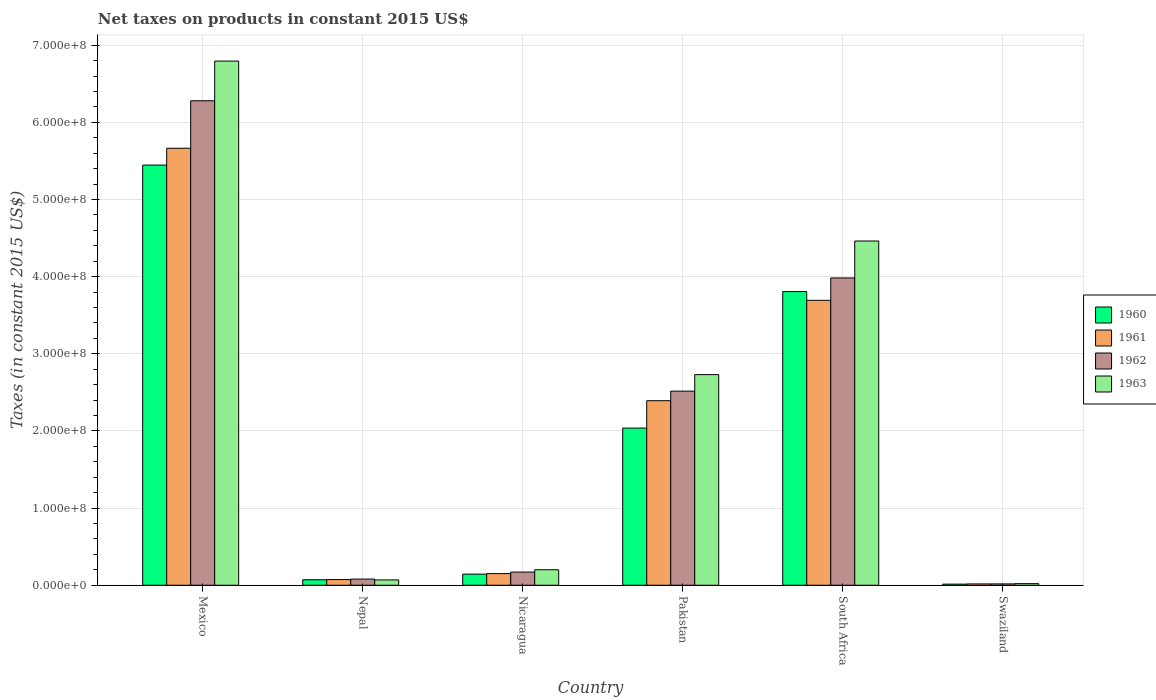How many different coloured bars are there?
Your answer should be very brief. 4. How many groups of bars are there?
Make the answer very short. 6. How many bars are there on the 1st tick from the right?
Keep it short and to the point. 4. What is the label of the 1st group of bars from the left?
Provide a succinct answer. Mexico. What is the net taxes on products in 1961 in Swaziland?
Provide a succinct answer. 1.69e+06. Across all countries, what is the maximum net taxes on products in 1960?
Your response must be concise. 5.45e+08. Across all countries, what is the minimum net taxes on products in 1963?
Keep it short and to the point. 2.06e+06. In which country was the net taxes on products in 1960 maximum?
Make the answer very short. Mexico. In which country was the net taxes on products in 1963 minimum?
Your response must be concise. Swaziland. What is the total net taxes on products in 1960 in the graph?
Ensure brevity in your answer.  1.15e+09. What is the difference between the net taxes on products in 1963 in Mexico and that in Nepal?
Offer a terse response. 6.72e+08. What is the difference between the net taxes on products in 1961 in Nepal and the net taxes on products in 1960 in South Africa?
Your answer should be very brief. -3.73e+08. What is the average net taxes on products in 1963 per country?
Your response must be concise. 2.38e+08. What is the difference between the net taxes on products of/in 1960 and net taxes on products of/in 1963 in Nepal?
Give a very brief answer. 1.97e+05. What is the ratio of the net taxes on products in 1961 in Mexico to that in South Africa?
Your answer should be compact. 1.53. Is the net taxes on products in 1962 in South Africa less than that in Swaziland?
Ensure brevity in your answer.  No. Is the difference between the net taxes on products in 1960 in Mexico and South Africa greater than the difference between the net taxes on products in 1963 in Mexico and South Africa?
Your answer should be compact. No. What is the difference between the highest and the second highest net taxes on products in 1962?
Offer a very short reply. 1.47e+08. What is the difference between the highest and the lowest net taxes on products in 1960?
Ensure brevity in your answer.  5.43e+08. How many countries are there in the graph?
Keep it short and to the point. 6. What is the difference between two consecutive major ticks on the Y-axis?
Make the answer very short. 1.00e+08. Are the values on the major ticks of Y-axis written in scientific E-notation?
Provide a short and direct response. Yes. Does the graph contain any zero values?
Provide a succinct answer. No. Does the graph contain grids?
Your answer should be compact. Yes. How many legend labels are there?
Your answer should be compact. 4. How are the legend labels stacked?
Keep it short and to the point. Vertical. What is the title of the graph?
Provide a short and direct response. Net taxes on products in constant 2015 US$. Does "2009" appear as one of the legend labels in the graph?
Your answer should be compact. No. What is the label or title of the Y-axis?
Your answer should be compact. Taxes (in constant 2015 US$). What is the Taxes (in constant 2015 US$) of 1960 in Mexico?
Keep it short and to the point. 5.45e+08. What is the Taxes (in constant 2015 US$) in 1961 in Mexico?
Ensure brevity in your answer.  5.66e+08. What is the Taxes (in constant 2015 US$) of 1962 in Mexico?
Make the answer very short. 6.28e+08. What is the Taxes (in constant 2015 US$) in 1963 in Mexico?
Your answer should be compact. 6.79e+08. What is the Taxes (in constant 2015 US$) in 1960 in Nepal?
Make the answer very short. 7.09e+06. What is the Taxes (in constant 2015 US$) of 1961 in Nepal?
Keep it short and to the point. 7.35e+06. What is the Taxes (in constant 2015 US$) in 1962 in Nepal?
Offer a very short reply. 8.01e+06. What is the Taxes (in constant 2015 US$) of 1963 in Nepal?
Provide a short and direct response. 6.89e+06. What is the Taxes (in constant 2015 US$) in 1960 in Nicaragua?
Provide a succinct answer. 1.44e+07. What is the Taxes (in constant 2015 US$) in 1961 in Nicaragua?
Offer a terse response. 1.51e+07. What is the Taxes (in constant 2015 US$) in 1962 in Nicaragua?
Offer a very short reply. 1.71e+07. What is the Taxes (in constant 2015 US$) in 1963 in Nicaragua?
Your answer should be compact. 2.01e+07. What is the Taxes (in constant 2015 US$) of 1960 in Pakistan?
Provide a succinct answer. 2.04e+08. What is the Taxes (in constant 2015 US$) of 1961 in Pakistan?
Give a very brief answer. 2.39e+08. What is the Taxes (in constant 2015 US$) of 1962 in Pakistan?
Offer a very short reply. 2.52e+08. What is the Taxes (in constant 2015 US$) in 1963 in Pakistan?
Provide a succinct answer. 2.73e+08. What is the Taxes (in constant 2015 US$) of 1960 in South Africa?
Offer a very short reply. 3.81e+08. What is the Taxes (in constant 2015 US$) in 1961 in South Africa?
Offer a very short reply. 3.69e+08. What is the Taxes (in constant 2015 US$) in 1962 in South Africa?
Ensure brevity in your answer.  3.98e+08. What is the Taxes (in constant 2015 US$) of 1963 in South Africa?
Make the answer very short. 4.46e+08. What is the Taxes (in constant 2015 US$) of 1960 in Swaziland?
Your answer should be compact. 1.40e+06. What is the Taxes (in constant 2015 US$) of 1961 in Swaziland?
Give a very brief answer. 1.69e+06. What is the Taxes (in constant 2015 US$) in 1962 in Swaziland?
Offer a terse response. 1.73e+06. What is the Taxes (in constant 2015 US$) in 1963 in Swaziland?
Provide a succinct answer. 2.06e+06. Across all countries, what is the maximum Taxes (in constant 2015 US$) of 1960?
Keep it short and to the point. 5.45e+08. Across all countries, what is the maximum Taxes (in constant 2015 US$) of 1961?
Ensure brevity in your answer.  5.66e+08. Across all countries, what is the maximum Taxes (in constant 2015 US$) of 1962?
Keep it short and to the point. 6.28e+08. Across all countries, what is the maximum Taxes (in constant 2015 US$) of 1963?
Make the answer very short. 6.79e+08. Across all countries, what is the minimum Taxes (in constant 2015 US$) of 1960?
Provide a short and direct response. 1.40e+06. Across all countries, what is the minimum Taxes (in constant 2015 US$) of 1961?
Your response must be concise. 1.69e+06. Across all countries, what is the minimum Taxes (in constant 2015 US$) of 1962?
Ensure brevity in your answer.  1.73e+06. Across all countries, what is the minimum Taxes (in constant 2015 US$) of 1963?
Offer a terse response. 2.06e+06. What is the total Taxes (in constant 2015 US$) of 1960 in the graph?
Keep it short and to the point. 1.15e+09. What is the total Taxes (in constant 2015 US$) in 1961 in the graph?
Make the answer very short. 1.20e+09. What is the total Taxes (in constant 2015 US$) of 1962 in the graph?
Your answer should be compact. 1.30e+09. What is the total Taxes (in constant 2015 US$) in 1963 in the graph?
Give a very brief answer. 1.43e+09. What is the difference between the Taxes (in constant 2015 US$) in 1960 in Mexico and that in Nepal?
Keep it short and to the point. 5.37e+08. What is the difference between the Taxes (in constant 2015 US$) of 1961 in Mexico and that in Nepal?
Provide a short and direct response. 5.59e+08. What is the difference between the Taxes (in constant 2015 US$) in 1962 in Mexico and that in Nepal?
Keep it short and to the point. 6.20e+08. What is the difference between the Taxes (in constant 2015 US$) in 1963 in Mexico and that in Nepal?
Offer a terse response. 6.72e+08. What is the difference between the Taxes (in constant 2015 US$) in 1960 in Mexico and that in Nicaragua?
Ensure brevity in your answer.  5.30e+08. What is the difference between the Taxes (in constant 2015 US$) in 1961 in Mexico and that in Nicaragua?
Your response must be concise. 5.51e+08. What is the difference between the Taxes (in constant 2015 US$) of 1962 in Mexico and that in Nicaragua?
Provide a short and direct response. 6.11e+08. What is the difference between the Taxes (in constant 2015 US$) of 1963 in Mexico and that in Nicaragua?
Offer a very short reply. 6.59e+08. What is the difference between the Taxes (in constant 2015 US$) of 1960 in Mexico and that in Pakistan?
Make the answer very short. 3.41e+08. What is the difference between the Taxes (in constant 2015 US$) of 1961 in Mexico and that in Pakistan?
Your answer should be compact. 3.27e+08. What is the difference between the Taxes (in constant 2015 US$) in 1962 in Mexico and that in Pakistan?
Keep it short and to the point. 3.76e+08. What is the difference between the Taxes (in constant 2015 US$) in 1963 in Mexico and that in Pakistan?
Keep it short and to the point. 4.06e+08. What is the difference between the Taxes (in constant 2015 US$) in 1960 in Mexico and that in South Africa?
Your response must be concise. 1.64e+08. What is the difference between the Taxes (in constant 2015 US$) in 1961 in Mexico and that in South Africa?
Your answer should be compact. 1.97e+08. What is the difference between the Taxes (in constant 2015 US$) of 1962 in Mexico and that in South Africa?
Your response must be concise. 2.30e+08. What is the difference between the Taxes (in constant 2015 US$) in 1963 in Mexico and that in South Africa?
Offer a terse response. 2.33e+08. What is the difference between the Taxes (in constant 2015 US$) in 1960 in Mexico and that in Swaziland?
Offer a very short reply. 5.43e+08. What is the difference between the Taxes (in constant 2015 US$) in 1961 in Mexico and that in Swaziland?
Provide a short and direct response. 5.65e+08. What is the difference between the Taxes (in constant 2015 US$) in 1962 in Mexico and that in Swaziland?
Keep it short and to the point. 6.26e+08. What is the difference between the Taxes (in constant 2015 US$) of 1963 in Mexico and that in Swaziland?
Keep it short and to the point. 6.77e+08. What is the difference between the Taxes (in constant 2015 US$) in 1960 in Nepal and that in Nicaragua?
Make the answer very short. -7.30e+06. What is the difference between the Taxes (in constant 2015 US$) of 1961 in Nepal and that in Nicaragua?
Your answer should be compact. -7.71e+06. What is the difference between the Taxes (in constant 2015 US$) of 1962 in Nepal and that in Nicaragua?
Your response must be concise. -9.06e+06. What is the difference between the Taxes (in constant 2015 US$) of 1963 in Nepal and that in Nicaragua?
Provide a short and direct response. -1.32e+07. What is the difference between the Taxes (in constant 2015 US$) in 1960 in Nepal and that in Pakistan?
Your response must be concise. -1.97e+08. What is the difference between the Taxes (in constant 2015 US$) in 1961 in Nepal and that in Pakistan?
Your answer should be compact. -2.32e+08. What is the difference between the Taxes (in constant 2015 US$) of 1962 in Nepal and that in Pakistan?
Ensure brevity in your answer.  -2.44e+08. What is the difference between the Taxes (in constant 2015 US$) of 1963 in Nepal and that in Pakistan?
Keep it short and to the point. -2.66e+08. What is the difference between the Taxes (in constant 2015 US$) of 1960 in Nepal and that in South Africa?
Your answer should be compact. -3.74e+08. What is the difference between the Taxes (in constant 2015 US$) in 1961 in Nepal and that in South Africa?
Ensure brevity in your answer.  -3.62e+08. What is the difference between the Taxes (in constant 2015 US$) of 1962 in Nepal and that in South Africa?
Your answer should be very brief. -3.90e+08. What is the difference between the Taxes (in constant 2015 US$) of 1963 in Nepal and that in South Africa?
Keep it short and to the point. -4.39e+08. What is the difference between the Taxes (in constant 2015 US$) of 1960 in Nepal and that in Swaziland?
Your answer should be compact. 5.68e+06. What is the difference between the Taxes (in constant 2015 US$) of 1961 in Nepal and that in Swaziland?
Your answer should be compact. 5.66e+06. What is the difference between the Taxes (in constant 2015 US$) of 1962 in Nepal and that in Swaziland?
Offer a very short reply. 6.27e+06. What is the difference between the Taxes (in constant 2015 US$) of 1963 in Nepal and that in Swaziland?
Your response must be concise. 4.83e+06. What is the difference between the Taxes (in constant 2015 US$) of 1960 in Nicaragua and that in Pakistan?
Ensure brevity in your answer.  -1.89e+08. What is the difference between the Taxes (in constant 2015 US$) in 1961 in Nicaragua and that in Pakistan?
Make the answer very short. -2.24e+08. What is the difference between the Taxes (in constant 2015 US$) in 1962 in Nicaragua and that in Pakistan?
Provide a short and direct response. -2.35e+08. What is the difference between the Taxes (in constant 2015 US$) in 1963 in Nicaragua and that in Pakistan?
Offer a very short reply. -2.53e+08. What is the difference between the Taxes (in constant 2015 US$) of 1960 in Nicaragua and that in South Africa?
Your response must be concise. -3.66e+08. What is the difference between the Taxes (in constant 2015 US$) in 1961 in Nicaragua and that in South Africa?
Give a very brief answer. -3.54e+08. What is the difference between the Taxes (in constant 2015 US$) in 1962 in Nicaragua and that in South Africa?
Offer a terse response. -3.81e+08. What is the difference between the Taxes (in constant 2015 US$) of 1963 in Nicaragua and that in South Africa?
Give a very brief answer. -4.26e+08. What is the difference between the Taxes (in constant 2015 US$) of 1960 in Nicaragua and that in Swaziland?
Ensure brevity in your answer.  1.30e+07. What is the difference between the Taxes (in constant 2015 US$) of 1961 in Nicaragua and that in Swaziland?
Your answer should be very brief. 1.34e+07. What is the difference between the Taxes (in constant 2015 US$) of 1962 in Nicaragua and that in Swaziland?
Ensure brevity in your answer.  1.53e+07. What is the difference between the Taxes (in constant 2015 US$) in 1963 in Nicaragua and that in Swaziland?
Provide a succinct answer. 1.80e+07. What is the difference between the Taxes (in constant 2015 US$) of 1960 in Pakistan and that in South Africa?
Your answer should be very brief. -1.77e+08. What is the difference between the Taxes (in constant 2015 US$) of 1961 in Pakistan and that in South Africa?
Offer a terse response. -1.30e+08. What is the difference between the Taxes (in constant 2015 US$) in 1962 in Pakistan and that in South Africa?
Your answer should be very brief. -1.47e+08. What is the difference between the Taxes (in constant 2015 US$) in 1963 in Pakistan and that in South Africa?
Offer a terse response. -1.73e+08. What is the difference between the Taxes (in constant 2015 US$) of 1960 in Pakistan and that in Swaziland?
Provide a succinct answer. 2.02e+08. What is the difference between the Taxes (in constant 2015 US$) of 1961 in Pakistan and that in Swaziland?
Ensure brevity in your answer.  2.37e+08. What is the difference between the Taxes (in constant 2015 US$) in 1962 in Pakistan and that in Swaziland?
Offer a very short reply. 2.50e+08. What is the difference between the Taxes (in constant 2015 US$) of 1963 in Pakistan and that in Swaziland?
Keep it short and to the point. 2.71e+08. What is the difference between the Taxes (in constant 2015 US$) in 1960 in South Africa and that in Swaziland?
Offer a very short reply. 3.79e+08. What is the difference between the Taxes (in constant 2015 US$) in 1961 in South Africa and that in Swaziland?
Keep it short and to the point. 3.68e+08. What is the difference between the Taxes (in constant 2015 US$) in 1962 in South Africa and that in Swaziland?
Provide a short and direct response. 3.97e+08. What is the difference between the Taxes (in constant 2015 US$) of 1963 in South Africa and that in Swaziland?
Make the answer very short. 4.44e+08. What is the difference between the Taxes (in constant 2015 US$) of 1960 in Mexico and the Taxes (in constant 2015 US$) of 1961 in Nepal?
Offer a terse response. 5.37e+08. What is the difference between the Taxes (in constant 2015 US$) of 1960 in Mexico and the Taxes (in constant 2015 US$) of 1962 in Nepal?
Your response must be concise. 5.37e+08. What is the difference between the Taxes (in constant 2015 US$) of 1960 in Mexico and the Taxes (in constant 2015 US$) of 1963 in Nepal?
Provide a succinct answer. 5.38e+08. What is the difference between the Taxes (in constant 2015 US$) in 1961 in Mexico and the Taxes (in constant 2015 US$) in 1962 in Nepal?
Offer a very short reply. 5.58e+08. What is the difference between the Taxes (in constant 2015 US$) in 1961 in Mexico and the Taxes (in constant 2015 US$) in 1963 in Nepal?
Give a very brief answer. 5.60e+08. What is the difference between the Taxes (in constant 2015 US$) of 1962 in Mexico and the Taxes (in constant 2015 US$) of 1963 in Nepal?
Offer a terse response. 6.21e+08. What is the difference between the Taxes (in constant 2015 US$) of 1960 in Mexico and the Taxes (in constant 2015 US$) of 1961 in Nicaragua?
Your answer should be very brief. 5.30e+08. What is the difference between the Taxes (in constant 2015 US$) of 1960 in Mexico and the Taxes (in constant 2015 US$) of 1962 in Nicaragua?
Provide a succinct answer. 5.28e+08. What is the difference between the Taxes (in constant 2015 US$) of 1960 in Mexico and the Taxes (in constant 2015 US$) of 1963 in Nicaragua?
Your answer should be compact. 5.24e+08. What is the difference between the Taxes (in constant 2015 US$) of 1961 in Mexico and the Taxes (in constant 2015 US$) of 1962 in Nicaragua?
Provide a short and direct response. 5.49e+08. What is the difference between the Taxes (in constant 2015 US$) in 1961 in Mexico and the Taxes (in constant 2015 US$) in 1963 in Nicaragua?
Ensure brevity in your answer.  5.46e+08. What is the difference between the Taxes (in constant 2015 US$) in 1962 in Mexico and the Taxes (in constant 2015 US$) in 1963 in Nicaragua?
Your answer should be compact. 6.08e+08. What is the difference between the Taxes (in constant 2015 US$) in 1960 in Mexico and the Taxes (in constant 2015 US$) in 1961 in Pakistan?
Your answer should be very brief. 3.05e+08. What is the difference between the Taxes (in constant 2015 US$) of 1960 in Mexico and the Taxes (in constant 2015 US$) of 1962 in Pakistan?
Offer a very short reply. 2.93e+08. What is the difference between the Taxes (in constant 2015 US$) in 1960 in Mexico and the Taxes (in constant 2015 US$) in 1963 in Pakistan?
Offer a terse response. 2.72e+08. What is the difference between the Taxes (in constant 2015 US$) in 1961 in Mexico and the Taxes (in constant 2015 US$) in 1962 in Pakistan?
Offer a very short reply. 3.15e+08. What is the difference between the Taxes (in constant 2015 US$) in 1961 in Mexico and the Taxes (in constant 2015 US$) in 1963 in Pakistan?
Provide a succinct answer. 2.93e+08. What is the difference between the Taxes (in constant 2015 US$) of 1962 in Mexico and the Taxes (in constant 2015 US$) of 1963 in Pakistan?
Offer a very short reply. 3.55e+08. What is the difference between the Taxes (in constant 2015 US$) in 1960 in Mexico and the Taxes (in constant 2015 US$) in 1961 in South Africa?
Offer a very short reply. 1.75e+08. What is the difference between the Taxes (in constant 2015 US$) of 1960 in Mexico and the Taxes (in constant 2015 US$) of 1962 in South Africa?
Ensure brevity in your answer.  1.46e+08. What is the difference between the Taxes (in constant 2015 US$) of 1960 in Mexico and the Taxes (in constant 2015 US$) of 1963 in South Africa?
Provide a short and direct response. 9.84e+07. What is the difference between the Taxes (in constant 2015 US$) of 1961 in Mexico and the Taxes (in constant 2015 US$) of 1962 in South Africa?
Your answer should be compact. 1.68e+08. What is the difference between the Taxes (in constant 2015 US$) in 1961 in Mexico and the Taxes (in constant 2015 US$) in 1963 in South Africa?
Keep it short and to the point. 1.20e+08. What is the difference between the Taxes (in constant 2015 US$) in 1962 in Mexico and the Taxes (in constant 2015 US$) in 1963 in South Africa?
Give a very brief answer. 1.82e+08. What is the difference between the Taxes (in constant 2015 US$) of 1960 in Mexico and the Taxes (in constant 2015 US$) of 1961 in Swaziland?
Make the answer very short. 5.43e+08. What is the difference between the Taxes (in constant 2015 US$) in 1960 in Mexico and the Taxes (in constant 2015 US$) in 1962 in Swaziland?
Make the answer very short. 5.43e+08. What is the difference between the Taxes (in constant 2015 US$) in 1960 in Mexico and the Taxes (in constant 2015 US$) in 1963 in Swaziland?
Offer a terse response. 5.43e+08. What is the difference between the Taxes (in constant 2015 US$) of 1961 in Mexico and the Taxes (in constant 2015 US$) of 1962 in Swaziland?
Provide a succinct answer. 5.65e+08. What is the difference between the Taxes (in constant 2015 US$) in 1961 in Mexico and the Taxes (in constant 2015 US$) in 1963 in Swaziland?
Offer a terse response. 5.64e+08. What is the difference between the Taxes (in constant 2015 US$) in 1962 in Mexico and the Taxes (in constant 2015 US$) in 1963 in Swaziland?
Keep it short and to the point. 6.26e+08. What is the difference between the Taxes (in constant 2015 US$) of 1960 in Nepal and the Taxes (in constant 2015 US$) of 1961 in Nicaragua?
Give a very brief answer. -7.97e+06. What is the difference between the Taxes (in constant 2015 US$) of 1960 in Nepal and the Taxes (in constant 2015 US$) of 1962 in Nicaragua?
Make the answer very short. -9.98e+06. What is the difference between the Taxes (in constant 2015 US$) in 1960 in Nepal and the Taxes (in constant 2015 US$) in 1963 in Nicaragua?
Your response must be concise. -1.30e+07. What is the difference between the Taxes (in constant 2015 US$) in 1961 in Nepal and the Taxes (in constant 2015 US$) in 1962 in Nicaragua?
Provide a short and direct response. -9.71e+06. What is the difference between the Taxes (in constant 2015 US$) in 1961 in Nepal and the Taxes (in constant 2015 US$) in 1963 in Nicaragua?
Your answer should be compact. -1.27e+07. What is the difference between the Taxes (in constant 2015 US$) in 1962 in Nepal and the Taxes (in constant 2015 US$) in 1963 in Nicaragua?
Your answer should be compact. -1.21e+07. What is the difference between the Taxes (in constant 2015 US$) of 1960 in Nepal and the Taxes (in constant 2015 US$) of 1961 in Pakistan?
Keep it short and to the point. -2.32e+08. What is the difference between the Taxes (in constant 2015 US$) in 1960 in Nepal and the Taxes (in constant 2015 US$) in 1962 in Pakistan?
Offer a terse response. -2.44e+08. What is the difference between the Taxes (in constant 2015 US$) in 1960 in Nepal and the Taxes (in constant 2015 US$) in 1963 in Pakistan?
Ensure brevity in your answer.  -2.66e+08. What is the difference between the Taxes (in constant 2015 US$) in 1961 in Nepal and the Taxes (in constant 2015 US$) in 1962 in Pakistan?
Make the answer very short. -2.44e+08. What is the difference between the Taxes (in constant 2015 US$) of 1961 in Nepal and the Taxes (in constant 2015 US$) of 1963 in Pakistan?
Offer a very short reply. -2.66e+08. What is the difference between the Taxes (in constant 2015 US$) of 1962 in Nepal and the Taxes (in constant 2015 US$) of 1963 in Pakistan?
Give a very brief answer. -2.65e+08. What is the difference between the Taxes (in constant 2015 US$) of 1960 in Nepal and the Taxes (in constant 2015 US$) of 1961 in South Africa?
Provide a succinct answer. -3.62e+08. What is the difference between the Taxes (in constant 2015 US$) in 1960 in Nepal and the Taxes (in constant 2015 US$) in 1962 in South Africa?
Provide a short and direct response. -3.91e+08. What is the difference between the Taxes (in constant 2015 US$) in 1960 in Nepal and the Taxes (in constant 2015 US$) in 1963 in South Africa?
Offer a very short reply. -4.39e+08. What is the difference between the Taxes (in constant 2015 US$) of 1961 in Nepal and the Taxes (in constant 2015 US$) of 1962 in South Africa?
Keep it short and to the point. -3.91e+08. What is the difference between the Taxes (in constant 2015 US$) of 1961 in Nepal and the Taxes (in constant 2015 US$) of 1963 in South Africa?
Offer a terse response. -4.39e+08. What is the difference between the Taxes (in constant 2015 US$) of 1962 in Nepal and the Taxes (in constant 2015 US$) of 1963 in South Africa?
Your answer should be very brief. -4.38e+08. What is the difference between the Taxes (in constant 2015 US$) in 1960 in Nepal and the Taxes (in constant 2015 US$) in 1961 in Swaziland?
Offer a very short reply. 5.39e+06. What is the difference between the Taxes (in constant 2015 US$) of 1960 in Nepal and the Taxes (in constant 2015 US$) of 1962 in Swaziland?
Your response must be concise. 5.35e+06. What is the difference between the Taxes (in constant 2015 US$) in 1960 in Nepal and the Taxes (in constant 2015 US$) in 1963 in Swaziland?
Your answer should be compact. 5.02e+06. What is the difference between the Taxes (in constant 2015 US$) of 1961 in Nepal and the Taxes (in constant 2015 US$) of 1962 in Swaziland?
Your answer should be very brief. 5.62e+06. What is the difference between the Taxes (in constant 2015 US$) of 1961 in Nepal and the Taxes (in constant 2015 US$) of 1963 in Swaziland?
Give a very brief answer. 5.29e+06. What is the difference between the Taxes (in constant 2015 US$) of 1962 in Nepal and the Taxes (in constant 2015 US$) of 1963 in Swaziland?
Provide a succinct answer. 5.94e+06. What is the difference between the Taxes (in constant 2015 US$) of 1960 in Nicaragua and the Taxes (in constant 2015 US$) of 1961 in Pakistan?
Make the answer very short. -2.25e+08. What is the difference between the Taxes (in constant 2015 US$) of 1960 in Nicaragua and the Taxes (in constant 2015 US$) of 1962 in Pakistan?
Provide a succinct answer. -2.37e+08. What is the difference between the Taxes (in constant 2015 US$) in 1960 in Nicaragua and the Taxes (in constant 2015 US$) in 1963 in Pakistan?
Offer a very short reply. -2.59e+08. What is the difference between the Taxes (in constant 2015 US$) in 1961 in Nicaragua and the Taxes (in constant 2015 US$) in 1962 in Pakistan?
Give a very brief answer. -2.37e+08. What is the difference between the Taxes (in constant 2015 US$) in 1961 in Nicaragua and the Taxes (in constant 2015 US$) in 1963 in Pakistan?
Give a very brief answer. -2.58e+08. What is the difference between the Taxes (in constant 2015 US$) in 1962 in Nicaragua and the Taxes (in constant 2015 US$) in 1963 in Pakistan?
Offer a very short reply. -2.56e+08. What is the difference between the Taxes (in constant 2015 US$) of 1960 in Nicaragua and the Taxes (in constant 2015 US$) of 1961 in South Africa?
Provide a short and direct response. -3.55e+08. What is the difference between the Taxes (in constant 2015 US$) in 1960 in Nicaragua and the Taxes (in constant 2015 US$) in 1962 in South Africa?
Give a very brief answer. -3.84e+08. What is the difference between the Taxes (in constant 2015 US$) in 1960 in Nicaragua and the Taxes (in constant 2015 US$) in 1963 in South Africa?
Your answer should be compact. -4.32e+08. What is the difference between the Taxes (in constant 2015 US$) of 1961 in Nicaragua and the Taxes (in constant 2015 US$) of 1962 in South Africa?
Your response must be concise. -3.83e+08. What is the difference between the Taxes (in constant 2015 US$) of 1961 in Nicaragua and the Taxes (in constant 2015 US$) of 1963 in South Africa?
Your answer should be very brief. -4.31e+08. What is the difference between the Taxes (in constant 2015 US$) in 1962 in Nicaragua and the Taxes (in constant 2015 US$) in 1963 in South Africa?
Keep it short and to the point. -4.29e+08. What is the difference between the Taxes (in constant 2015 US$) of 1960 in Nicaragua and the Taxes (in constant 2015 US$) of 1961 in Swaziland?
Your answer should be very brief. 1.27e+07. What is the difference between the Taxes (in constant 2015 US$) of 1960 in Nicaragua and the Taxes (in constant 2015 US$) of 1962 in Swaziland?
Provide a short and direct response. 1.27e+07. What is the difference between the Taxes (in constant 2015 US$) of 1960 in Nicaragua and the Taxes (in constant 2015 US$) of 1963 in Swaziland?
Your response must be concise. 1.23e+07. What is the difference between the Taxes (in constant 2015 US$) of 1961 in Nicaragua and the Taxes (in constant 2015 US$) of 1962 in Swaziland?
Provide a short and direct response. 1.33e+07. What is the difference between the Taxes (in constant 2015 US$) in 1961 in Nicaragua and the Taxes (in constant 2015 US$) in 1963 in Swaziland?
Provide a succinct answer. 1.30e+07. What is the difference between the Taxes (in constant 2015 US$) in 1962 in Nicaragua and the Taxes (in constant 2015 US$) in 1963 in Swaziland?
Provide a short and direct response. 1.50e+07. What is the difference between the Taxes (in constant 2015 US$) of 1960 in Pakistan and the Taxes (in constant 2015 US$) of 1961 in South Africa?
Provide a succinct answer. -1.66e+08. What is the difference between the Taxes (in constant 2015 US$) in 1960 in Pakistan and the Taxes (in constant 2015 US$) in 1962 in South Africa?
Your response must be concise. -1.95e+08. What is the difference between the Taxes (in constant 2015 US$) of 1960 in Pakistan and the Taxes (in constant 2015 US$) of 1963 in South Africa?
Offer a very short reply. -2.42e+08. What is the difference between the Taxes (in constant 2015 US$) of 1961 in Pakistan and the Taxes (in constant 2015 US$) of 1962 in South Africa?
Make the answer very short. -1.59e+08. What is the difference between the Taxes (in constant 2015 US$) in 1961 in Pakistan and the Taxes (in constant 2015 US$) in 1963 in South Africa?
Provide a short and direct response. -2.07e+08. What is the difference between the Taxes (in constant 2015 US$) in 1962 in Pakistan and the Taxes (in constant 2015 US$) in 1963 in South Africa?
Your answer should be compact. -1.95e+08. What is the difference between the Taxes (in constant 2015 US$) in 1960 in Pakistan and the Taxes (in constant 2015 US$) in 1961 in Swaziland?
Your answer should be very brief. 2.02e+08. What is the difference between the Taxes (in constant 2015 US$) of 1960 in Pakistan and the Taxes (in constant 2015 US$) of 1962 in Swaziland?
Offer a very short reply. 2.02e+08. What is the difference between the Taxes (in constant 2015 US$) in 1960 in Pakistan and the Taxes (in constant 2015 US$) in 1963 in Swaziland?
Ensure brevity in your answer.  2.02e+08. What is the difference between the Taxes (in constant 2015 US$) in 1961 in Pakistan and the Taxes (in constant 2015 US$) in 1962 in Swaziland?
Keep it short and to the point. 2.37e+08. What is the difference between the Taxes (in constant 2015 US$) in 1961 in Pakistan and the Taxes (in constant 2015 US$) in 1963 in Swaziland?
Offer a terse response. 2.37e+08. What is the difference between the Taxes (in constant 2015 US$) in 1962 in Pakistan and the Taxes (in constant 2015 US$) in 1963 in Swaziland?
Your answer should be very brief. 2.50e+08. What is the difference between the Taxes (in constant 2015 US$) in 1960 in South Africa and the Taxes (in constant 2015 US$) in 1961 in Swaziland?
Give a very brief answer. 3.79e+08. What is the difference between the Taxes (in constant 2015 US$) in 1960 in South Africa and the Taxes (in constant 2015 US$) in 1962 in Swaziland?
Your response must be concise. 3.79e+08. What is the difference between the Taxes (in constant 2015 US$) of 1960 in South Africa and the Taxes (in constant 2015 US$) of 1963 in Swaziland?
Ensure brevity in your answer.  3.79e+08. What is the difference between the Taxes (in constant 2015 US$) in 1961 in South Africa and the Taxes (in constant 2015 US$) in 1962 in Swaziland?
Provide a short and direct response. 3.68e+08. What is the difference between the Taxes (in constant 2015 US$) of 1961 in South Africa and the Taxes (in constant 2015 US$) of 1963 in Swaziland?
Offer a terse response. 3.67e+08. What is the difference between the Taxes (in constant 2015 US$) of 1962 in South Africa and the Taxes (in constant 2015 US$) of 1963 in Swaziland?
Ensure brevity in your answer.  3.96e+08. What is the average Taxes (in constant 2015 US$) of 1960 per country?
Provide a succinct answer. 1.92e+08. What is the average Taxes (in constant 2015 US$) of 1961 per country?
Offer a terse response. 2.00e+08. What is the average Taxes (in constant 2015 US$) of 1962 per country?
Your answer should be compact. 2.17e+08. What is the average Taxes (in constant 2015 US$) in 1963 per country?
Keep it short and to the point. 2.38e+08. What is the difference between the Taxes (in constant 2015 US$) of 1960 and Taxes (in constant 2015 US$) of 1961 in Mexico?
Your answer should be very brief. -2.18e+07. What is the difference between the Taxes (in constant 2015 US$) in 1960 and Taxes (in constant 2015 US$) in 1962 in Mexico?
Ensure brevity in your answer.  -8.34e+07. What is the difference between the Taxes (in constant 2015 US$) in 1960 and Taxes (in constant 2015 US$) in 1963 in Mexico?
Ensure brevity in your answer.  -1.35e+08. What is the difference between the Taxes (in constant 2015 US$) in 1961 and Taxes (in constant 2015 US$) in 1962 in Mexico?
Your answer should be very brief. -6.15e+07. What is the difference between the Taxes (in constant 2015 US$) of 1961 and Taxes (in constant 2015 US$) of 1963 in Mexico?
Your response must be concise. -1.13e+08. What is the difference between the Taxes (in constant 2015 US$) of 1962 and Taxes (in constant 2015 US$) of 1963 in Mexico?
Offer a terse response. -5.14e+07. What is the difference between the Taxes (in constant 2015 US$) in 1960 and Taxes (in constant 2015 US$) in 1961 in Nepal?
Provide a succinct answer. -2.63e+05. What is the difference between the Taxes (in constant 2015 US$) in 1960 and Taxes (in constant 2015 US$) in 1962 in Nepal?
Keep it short and to the point. -9.19e+05. What is the difference between the Taxes (in constant 2015 US$) of 1960 and Taxes (in constant 2015 US$) of 1963 in Nepal?
Keep it short and to the point. 1.97e+05. What is the difference between the Taxes (in constant 2015 US$) in 1961 and Taxes (in constant 2015 US$) in 1962 in Nepal?
Offer a very short reply. -6.56e+05. What is the difference between the Taxes (in constant 2015 US$) in 1961 and Taxes (in constant 2015 US$) in 1963 in Nepal?
Provide a succinct answer. 4.60e+05. What is the difference between the Taxes (in constant 2015 US$) in 1962 and Taxes (in constant 2015 US$) in 1963 in Nepal?
Offer a very short reply. 1.12e+06. What is the difference between the Taxes (in constant 2015 US$) in 1960 and Taxes (in constant 2015 US$) in 1961 in Nicaragua?
Keep it short and to the point. -6.69e+05. What is the difference between the Taxes (in constant 2015 US$) in 1960 and Taxes (in constant 2015 US$) in 1962 in Nicaragua?
Your answer should be compact. -2.68e+06. What is the difference between the Taxes (in constant 2015 US$) in 1960 and Taxes (in constant 2015 US$) in 1963 in Nicaragua?
Make the answer very short. -5.69e+06. What is the difference between the Taxes (in constant 2015 US$) in 1961 and Taxes (in constant 2015 US$) in 1962 in Nicaragua?
Keep it short and to the point. -2.01e+06. What is the difference between the Taxes (in constant 2015 US$) in 1961 and Taxes (in constant 2015 US$) in 1963 in Nicaragua?
Make the answer very short. -5.02e+06. What is the difference between the Taxes (in constant 2015 US$) of 1962 and Taxes (in constant 2015 US$) of 1963 in Nicaragua?
Offer a terse response. -3.01e+06. What is the difference between the Taxes (in constant 2015 US$) in 1960 and Taxes (in constant 2015 US$) in 1961 in Pakistan?
Give a very brief answer. -3.55e+07. What is the difference between the Taxes (in constant 2015 US$) in 1960 and Taxes (in constant 2015 US$) in 1962 in Pakistan?
Offer a terse response. -4.79e+07. What is the difference between the Taxes (in constant 2015 US$) in 1960 and Taxes (in constant 2015 US$) in 1963 in Pakistan?
Your answer should be very brief. -6.93e+07. What is the difference between the Taxes (in constant 2015 US$) in 1961 and Taxes (in constant 2015 US$) in 1962 in Pakistan?
Your answer should be very brief. -1.24e+07. What is the difference between the Taxes (in constant 2015 US$) of 1961 and Taxes (in constant 2015 US$) of 1963 in Pakistan?
Your answer should be very brief. -3.38e+07. What is the difference between the Taxes (in constant 2015 US$) in 1962 and Taxes (in constant 2015 US$) in 1963 in Pakistan?
Make the answer very short. -2.14e+07. What is the difference between the Taxes (in constant 2015 US$) of 1960 and Taxes (in constant 2015 US$) of 1961 in South Africa?
Ensure brevity in your answer.  1.13e+07. What is the difference between the Taxes (in constant 2015 US$) of 1960 and Taxes (in constant 2015 US$) of 1962 in South Africa?
Provide a succinct answer. -1.76e+07. What is the difference between the Taxes (in constant 2015 US$) in 1960 and Taxes (in constant 2015 US$) in 1963 in South Africa?
Your answer should be very brief. -6.55e+07. What is the difference between the Taxes (in constant 2015 US$) of 1961 and Taxes (in constant 2015 US$) of 1962 in South Africa?
Keep it short and to the point. -2.90e+07. What is the difference between the Taxes (in constant 2015 US$) of 1961 and Taxes (in constant 2015 US$) of 1963 in South Africa?
Keep it short and to the point. -7.69e+07. What is the difference between the Taxes (in constant 2015 US$) of 1962 and Taxes (in constant 2015 US$) of 1963 in South Africa?
Provide a succinct answer. -4.79e+07. What is the difference between the Taxes (in constant 2015 US$) of 1960 and Taxes (in constant 2015 US$) of 1961 in Swaziland?
Offer a very short reply. -2.89e+05. What is the difference between the Taxes (in constant 2015 US$) of 1960 and Taxes (in constant 2015 US$) of 1962 in Swaziland?
Provide a succinct answer. -3.30e+05. What is the difference between the Taxes (in constant 2015 US$) in 1960 and Taxes (in constant 2015 US$) in 1963 in Swaziland?
Offer a very short reply. -6.61e+05. What is the difference between the Taxes (in constant 2015 US$) in 1961 and Taxes (in constant 2015 US$) in 1962 in Swaziland?
Your answer should be very brief. -4.13e+04. What is the difference between the Taxes (in constant 2015 US$) in 1961 and Taxes (in constant 2015 US$) in 1963 in Swaziland?
Give a very brief answer. -3.72e+05. What is the difference between the Taxes (in constant 2015 US$) of 1962 and Taxes (in constant 2015 US$) of 1963 in Swaziland?
Ensure brevity in your answer.  -3.30e+05. What is the ratio of the Taxes (in constant 2015 US$) in 1960 in Mexico to that in Nepal?
Keep it short and to the point. 76.83. What is the ratio of the Taxes (in constant 2015 US$) in 1961 in Mexico to that in Nepal?
Provide a succinct answer. 77.06. What is the ratio of the Taxes (in constant 2015 US$) in 1962 in Mexico to that in Nepal?
Ensure brevity in your answer.  78.43. What is the ratio of the Taxes (in constant 2015 US$) of 1963 in Mexico to that in Nepal?
Offer a terse response. 98.6. What is the ratio of the Taxes (in constant 2015 US$) in 1960 in Mexico to that in Nicaragua?
Ensure brevity in your answer.  37.85. What is the ratio of the Taxes (in constant 2015 US$) in 1961 in Mexico to that in Nicaragua?
Keep it short and to the point. 37.62. What is the ratio of the Taxes (in constant 2015 US$) of 1962 in Mexico to that in Nicaragua?
Provide a short and direct response. 36.8. What is the ratio of the Taxes (in constant 2015 US$) of 1963 in Mexico to that in Nicaragua?
Provide a succinct answer. 33.84. What is the ratio of the Taxes (in constant 2015 US$) in 1960 in Mexico to that in Pakistan?
Provide a short and direct response. 2.67. What is the ratio of the Taxes (in constant 2015 US$) in 1961 in Mexico to that in Pakistan?
Give a very brief answer. 2.37. What is the ratio of the Taxes (in constant 2015 US$) in 1962 in Mexico to that in Pakistan?
Give a very brief answer. 2.5. What is the ratio of the Taxes (in constant 2015 US$) in 1963 in Mexico to that in Pakistan?
Keep it short and to the point. 2.49. What is the ratio of the Taxes (in constant 2015 US$) of 1960 in Mexico to that in South Africa?
Your answer should be compact. 1.43. What is the ratio of the Taxes (in constant 2015 US$) in 1961 in Mexico to that in South Africa?
Provide a short and direct response. 1.53. What is the ratio of the Taxes (in constant 2015 US$) of 1962 in Mexico to that in South Africa?
Give a very brief answer. 1.58. What is the ratio of the Taxes (in constant 2015 US$) of 1963 in Mexico to that in South Africa?
Your answer should be compact. 1.52. What is the ratio of the Taxes (in constant 2015 US$) in 1960 in Mexico to that in Swaziland?
Provide a short and direct response. 387.97. What is the ratio of the Taxes (in constant 2015 US$) in 1961 in Mexico to that in Swaziland?
Offer a terse response. 334.64. What is the ratio of the Taxes (in constant 2015 US$) of 1962 in Mexico to that in Swaziland?
Your answer should be compact. 362.15. What is the ratio of the Taxes (in constant 2015 US$) of 1963 in Mexico to that in Swaziland?
Your response must be concise. 329.13. What is the ratio of the Taxes (in constant 2015 US$) of 1960 in Nepal to that in Nicaragua?
Ensure brevity in your answer.  0.49. What is the ratio of the Taxes (in constant 2015 US$) of 1961 in Nepal to that in Nicaragua?
Provide a short and direct response. 0.49. What is the ratio of the Taxes (in constant 2015 US$) of 1962 in Nepal to that in Nicaragua?
Ensure brevity in your answer.  0.47. What is the ratio of the Taxes (in constant 2015 US$) in 1963 in Nepal to that in Nicaragua?
Your response must be concise. 0.34. What is the ratio of the Taxes (in constant 2015 US$) of 1960 in Nepal to that in Pakistan?
Your response must be concise. 0.03. What is the ratio of the Taxes (in constant 2015 US$) in 1961 in Nepal to that in Pakistan?
Ensure brevity in your answer.  0.03. What is the ratio of the Taxes (in constant 2015 US$) in 1962 in Nepal to that in Pakistan?
Offer a terse response. 0.03. What is the ratio of the Taxes (in constant 2015 US$) in 1963 in Nepal to that in Pakistan?
Offer a terse response. 0.03. What is the ratio of the Taxes (in constant 2015 US$) in 1960 in Nepal to that in South Africa?
Your response must be concise. 0.02. What is the ratio of the Taxes (in constant 2015 US$) of 1961 in Nepal to that in South Africa?
Give a very brief answer. 0.02. What is the ratio of the Taxes (in constant 2015 US$) in 1962 in Nepal to that in South Africa?
Ensure brevity in your answer.  0.02. What is the ratio of the Taxes (in constant 2015 US$) of 1963 in Nepal to that in South Africa?
Provide a succinct answer. 0.02. What is the ratio of the Taxes (in constant 2015 US$) of 1960 in Nepal to that in Swaziland?
Provide a succinct answer. 5.05. What is the ratio of the Taxes (in constant 2015 US$) in 1961 in Nepal to that in Swaziland?
Make the answer very short. 4.34. What is the ratio of the Taxes (in constant 2015 US$) in 1962 in Nepal to that in Swaziland?
Your response must be concise. 4.62. What is the ratio of the Taxes (in constant 2015 US$) in 1963 in Nepal to that in Swaziland?
Make the answer very short. 3.34. What is the ratio of the Taxes (in constant 2015 US$) of 1960 in Nicaragua to that in Pakistan?
Give a very brief answer. 0.07. What is the ratio of the Taxes (in constant 2015 US$) in 1961 in Nicaragua to that in Pakistan?
Offer a terse response. 0.06. What is the ratio of the Taxes (in constant 2015 US$) of 1962 in Nicaragua to that in Pakistan?
Provide a short and direct response. 0.07. What is the ratio of the Taxes (in constant 2015 US$) in 1963 in Nicaragua to that in Pakistan?
Offer a very short reply. 0.07. What is the ratio of the Taxes (in constant 2015 US$) of 1960 in Nicaragua to that in South Africa?
Keep it short and to the point. 0.04. What is the ratio of the Taxes (in constant 2015 US$) in 1961 in Nicaragua to that in South Africa?
Provide a succinct answer. 0.04. What is the ratio of the Taxes (in constant 2015 US$) in 1962 in Nicaragua to that in South Africa?
Your answer should be very brief. 0.04. What is the ratio of the Taxes (in constant 2015 US$) in 1963 in Nicaragua to that in South Africa?
Ensure brevity in your answer.  0.04. What is the ratio of the Taxes (in constant 2015 US$) in 1960 in Nicaragua to that in Swaziland?
Offer a very short reply. 10.25. What is the ratio of the Taxes (in constant 2015 US$) in 1961 in Nicaragua to that in Swaziland?
Make the answer very short. 8.89. What is the ratio of the Taxes (in constant 2015 US$) in 1962 in Nicaragua to that in Swaziland?
Make the answer very short. 9.84. What is the ratio of the Taxes (in constant 2015 US$) in 1963 in Nicaragua to that in Swaziland?
Provide a succinct answer. 9.73. What is the ratio of the Taxes (in constant 2015 US$) in 1960 in Pakistan to that in South Africa?
Keep it short and to the point. 0.54. What is the ratio of the Taxes (in constant 2015 US$) in 1961 in Pakistan to that in South Africa?
Your answer should be compact. 0.65. What is the ratio of the Taxes (in constant 2015 US$) in 1962 in Pakistan to that in South Africa?
Offer a very short reply. 0.63. What is the ratio of the Taxes (in constant 2015 US$) in 1963 in Pakistan to that in South Africa?
Give a very brief answer. 0.61. What is the ratio of the Taxes (in constant 2015 US$) of 1960 in Pakistan to that in Swaziland?
Provide a short and direct response. 145.12. What is the ratio of the Taxes (in constant 2015 US$) in 1961 in Pakistan to that in Swaziland?
Offer a terse response. 141.31. What is the ratio of the Taxes (in constant 2015 US$) of 1962 in Pakistan to that in Swaziland?
Keep it short and to the point. 145.09. What is the ratio of the Taxes (in constant 2015 US$) of 1963 in Pakistan to that in Swaziland?
Keep it short and to the point. 132.25. What is the ratio of the Taxes (in constant 2015 US$) of 1960 in South Africa to that in Swaziland?
Offer a terse response. 271.17. What is the ratio of the Taxes (in constant 2015 US$) in 1961 in South Africa to that in Swaziland?
Offer a terse response. 218.17. What is the ratio of the Taxes (in constant 2015 US$) in 1962 in South Africa to that in Swaziland?
Make the answer very short. 229.69. What is the ratio of the Taxes (in constant 2015 US$) in 1963 in South Africa to that in Swaziland?
Your answer should be very brief. 216.15. What is the difference between the highest and the second highest Taxes (in constant 2015 US$) of 1960?
Give a very brief answer. 1.64e+08. What is the difference between the highest and the second highest Taxes (in constant 2015 US$) in 1961?
Provide a succinct answer. 1.97e+08. What is the difference between the highest and the second highest Taxes (in constant 2015 US$) of 1962?
Your response must be concise. 2.30e+08. What is the difference between the highest and the second highest Taxes (in constant 2015 US$) in 1963?
Provide a succinct answer. 2.33e+08. What is the difference between the highest and the lowest Taxes (in constant 2015 US$) in 1960?
Keep it short and to the point. 5.43e+08. What is the difference between the highest and the lowest Taxes (in constant 2015 US$) in 1961?
Your answer should be very brief. 5.65e+08. What is the difference between the highest and the lowest Taxes (in constant 2015 US$) of 1962?
Offer a very short reply. 6.26e+08. What is the difference between the highest and the lowest Taxes (in constant 2015 US$) in 1963?
Your answer should be very brief. 6.77e+08. 